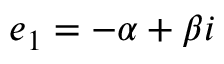Convert formula to latex. <formula><loc_0><loc_0><loc_500><loc_500>e _ { 1 } = - \alpha + \beta i</formula> 